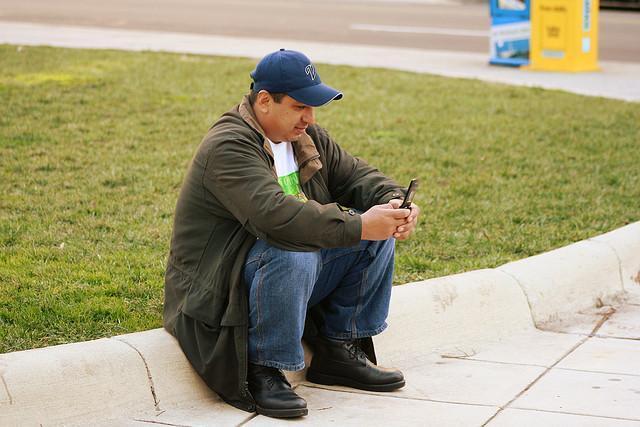How many people are there?
Give a very brief answer. 1. How many train cars are behind the locomotive?
Give a very brief answer. 0. 